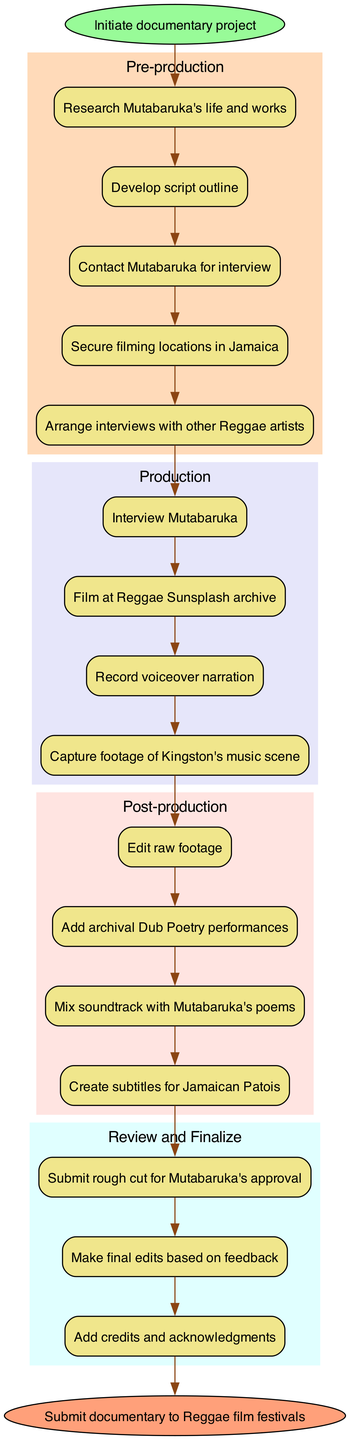What is the starting point of the documentary process? The starting point node is labeled "Initiate documentary project," indicating the first action in the sequence.
Answer: Initiate documentary project How many tasks are in the pre-production phase? There are five distinct tasks listed under the pre-production phase, which can be counted directly from the diagram structure.
Answer: 5 What is the last task in the production phase? The last task node within the production phase states "Capture footage of Kingston's music scene," providing the conclusive action of that stage.
Answer: Capture footage of Kingston's music scene Which phase follows post-production in the diagram? The diagram illustrates an edge connecting post-production to review and finalize, indicating that review and finalize is the subsequent phase after post-production.
Answer: Review and Finalize What task comes immediately before the final submission of the documentary? The task directly before the end node labeled "Submit documentary to Reggae film festivals" is "Add credits and acknowledgments," showing the last action taken before the submission.
Answer: Add credits and acknowledgments How many major phases are represented in the diagram? The diagram clearly groups actions into four major phases: pre-production, production, post-production, and review and finalize, which can be counted from the main clusters.
Answer: 4 Which task involves Mutabaruka directly? "Interview Mutabaruka" is a task explicitly mentioning Mutabaruka, indicating his direct involvement in the process.
Answer: Interview Mutabaruka What is the relationship between editing and adding archival performances? The diagram shows that "Edit raw footage" in the post-production phase is connected to the following task "Add archival Dub Poetry performances," indicating that editing occurs before adding archival material.
Answer: Edit raw footage What color represents the post-production phase in the diagram? The post-production phase is indicated in soft pink, specifically labeled with the color #FFE4E1, which can be recognized from the diagram's attributes.
Answer: Pink 